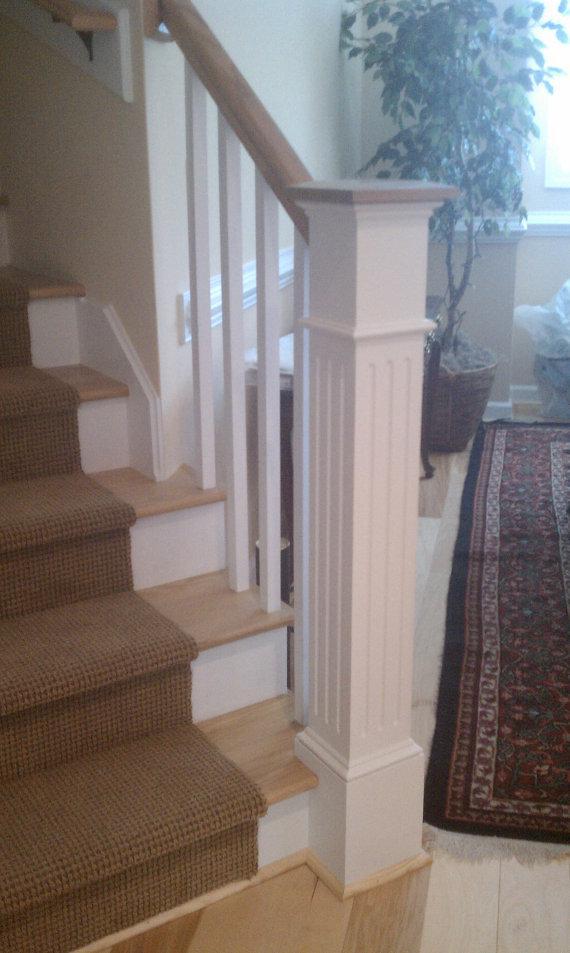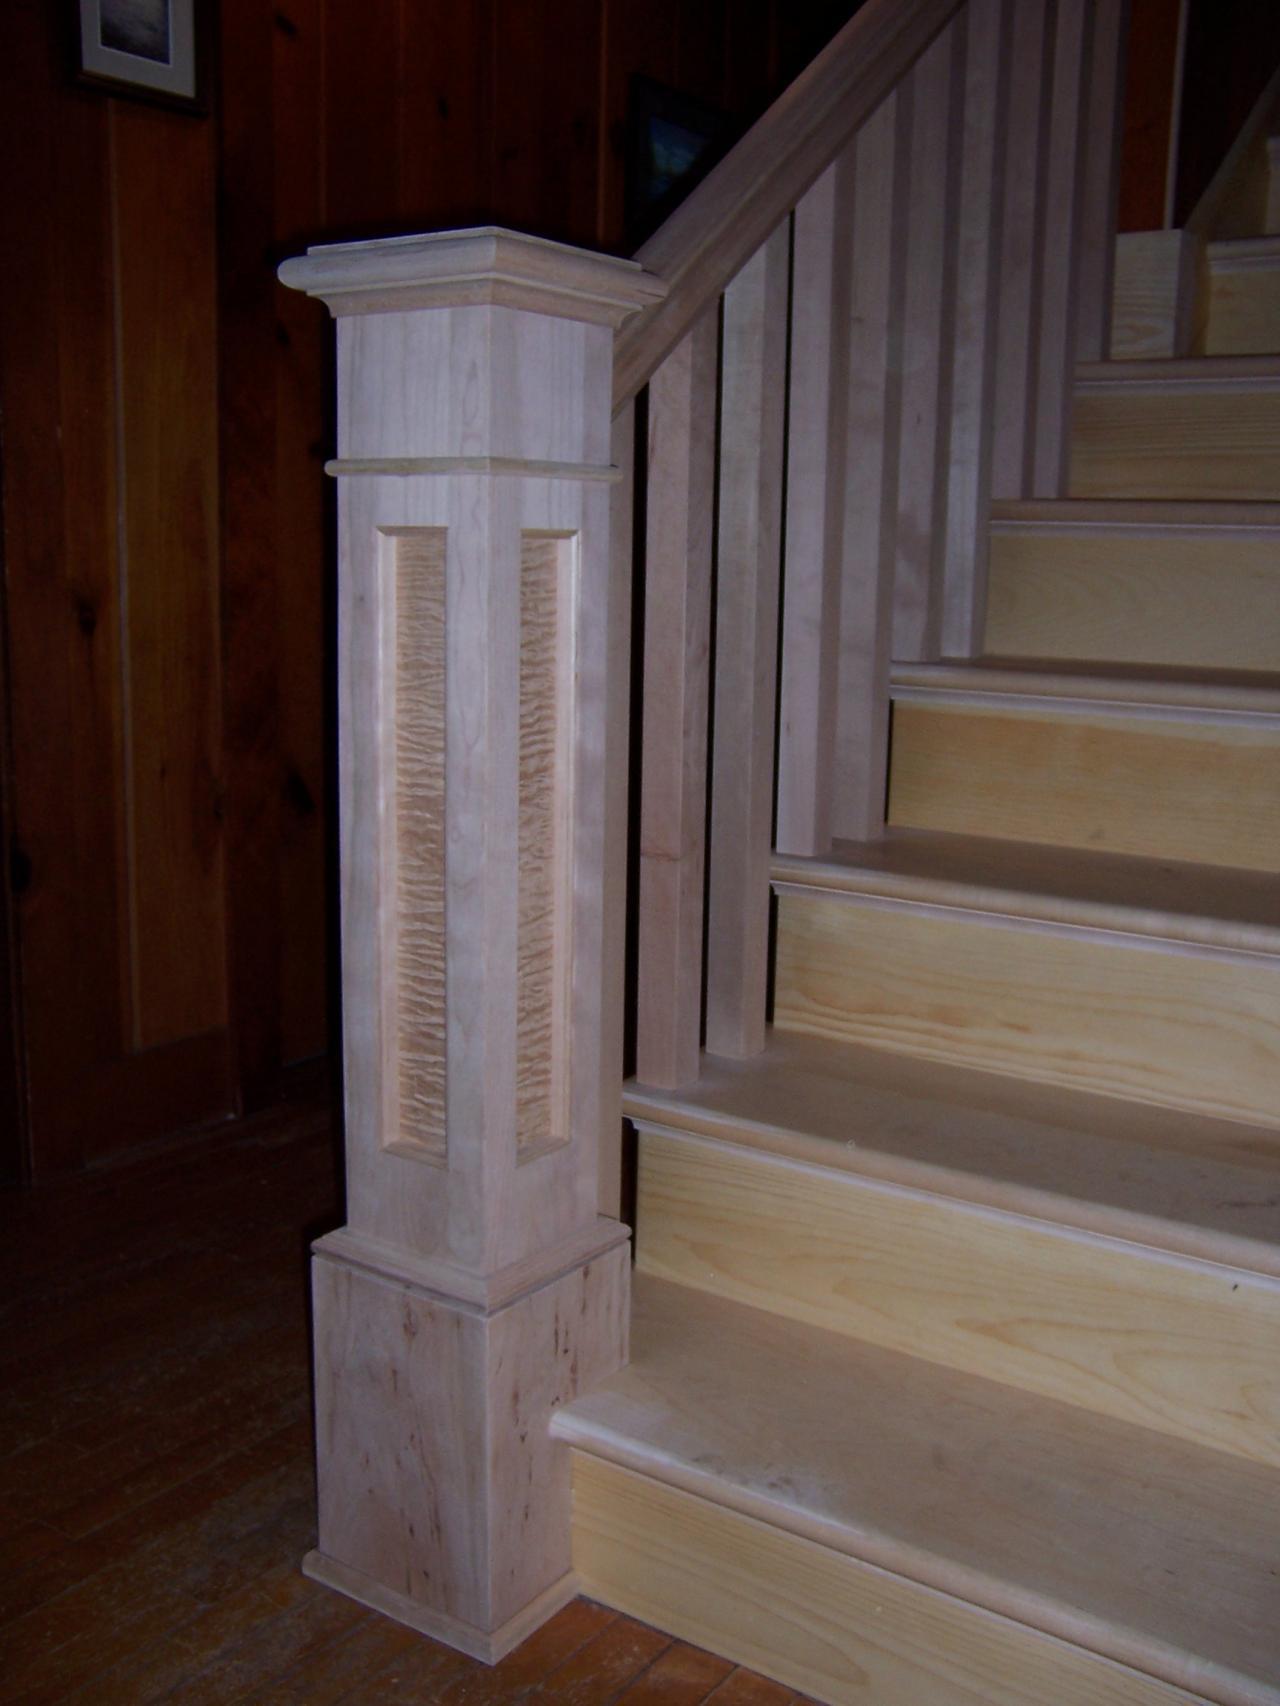The first image is the image on the left, the second image is the image on the right. Given the left and right images, does the statement "In one image, at least one newel post is at the bottom of stairs, but in the second image, two newel posts are at the top of stairs." hold true? Answer yes or no. No. The first image is the image on the left, the second image is the image on the right. Analyze the images presented: Is the assertion "there is a srairway being shown from the top floor, the rails are white and the top rail is painted black" valid? Answer yes or no. No. 